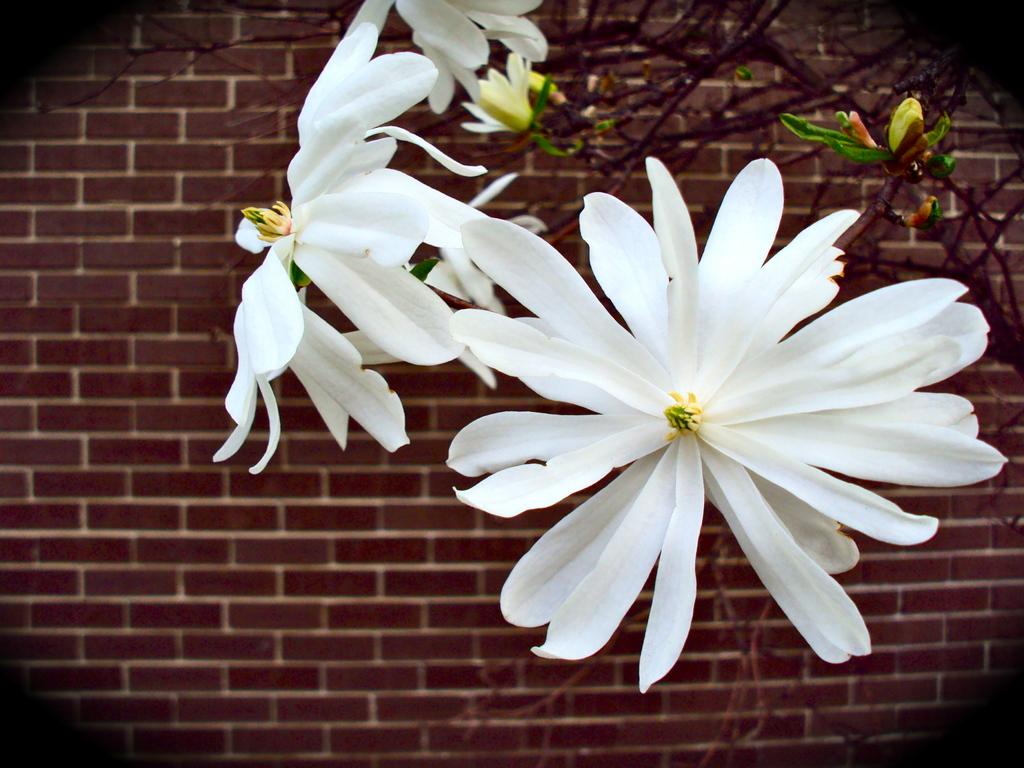What type of plant life is visible in the image? There are flowers, buds, leaves, and stems visible in the image. Can you describe the different parts of the plants in the image? Yes, there are flowers, buds, leaves, and stems present in the image. What is visible in the background of the image? There is a wall in the background of the image. How many icicles are hanging from the flowers in the image? There are no icicles present in the image; it features flowers, buds, leaves, and stems. 